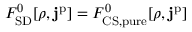<formula> <loc_0><loc_0><loc_500><loc_500>F _ { S D } ^ { 0 } [ \rho , j ^ { p } ] = F _ { C S , p u r e } ^ { 0 } [ \rho , j ^ { p } ]</formula> 